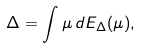Convert formula to latex. <formula><loc_0><loc_0><loc_500><loc_500>\Delta = \int \mu \, d E _ { \Delta } ( \mu ) ,</formula> 